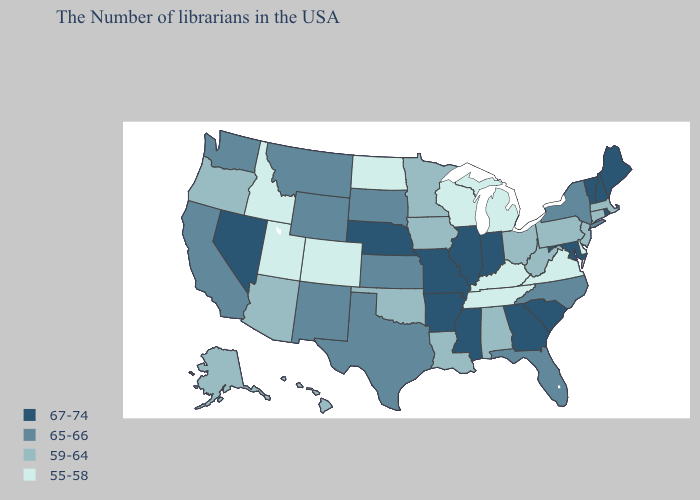Does Minnesota have the highest value in the MidWest?
Quick response, please. No. What is the lowest value in states that border North Dakota?
Quick response, please. 59-64. Name the states that have a value in the range 55-58?
Short answer required. Delaware, Virginia, Michigan, Kentucky, Tennessee, Wisconsin, North Dakota, Colorado, Utah, Idaho. What is the value of Colorado?
Keep it brief. 55-58. What is the lowest value in states that border Minnesota?
Answer briefly. 55-58. Among the states that border Florida , which have the highest value?
Write a very short answer. Georgia. What is the lowest value in states that border Kansas?
Concise answer only. 55-58. Does the first symbol in the legend represent the smallest category?
Give a very brief answer. No. Does the map have missing data?
Give a very brief answer. No. Does California have the highest value in the USA?
Keep it brief. No. Name the states that have a value in the range 55-58?
Write a very short answer. Delaware, Virginia, Michigan, Kentucky, Tennessee, Wisconsin, North Dakota, Colorado, Utah, Idaho. Does Montana have the same value as Mississippi?
Be succinct. No. What is the value of Iowa?
Concise answer only. 59-64. Among the states that border Kansas , which have the highest value?
Concise answer only. Missouri, Nebraska. Name the states that have a value in the range 65-66?
Write a very short answer. New York, North Carolina, Florida, Kansas, Texas, South Dakota, Wyoming, New Mexico, Montana, California, Washington. 